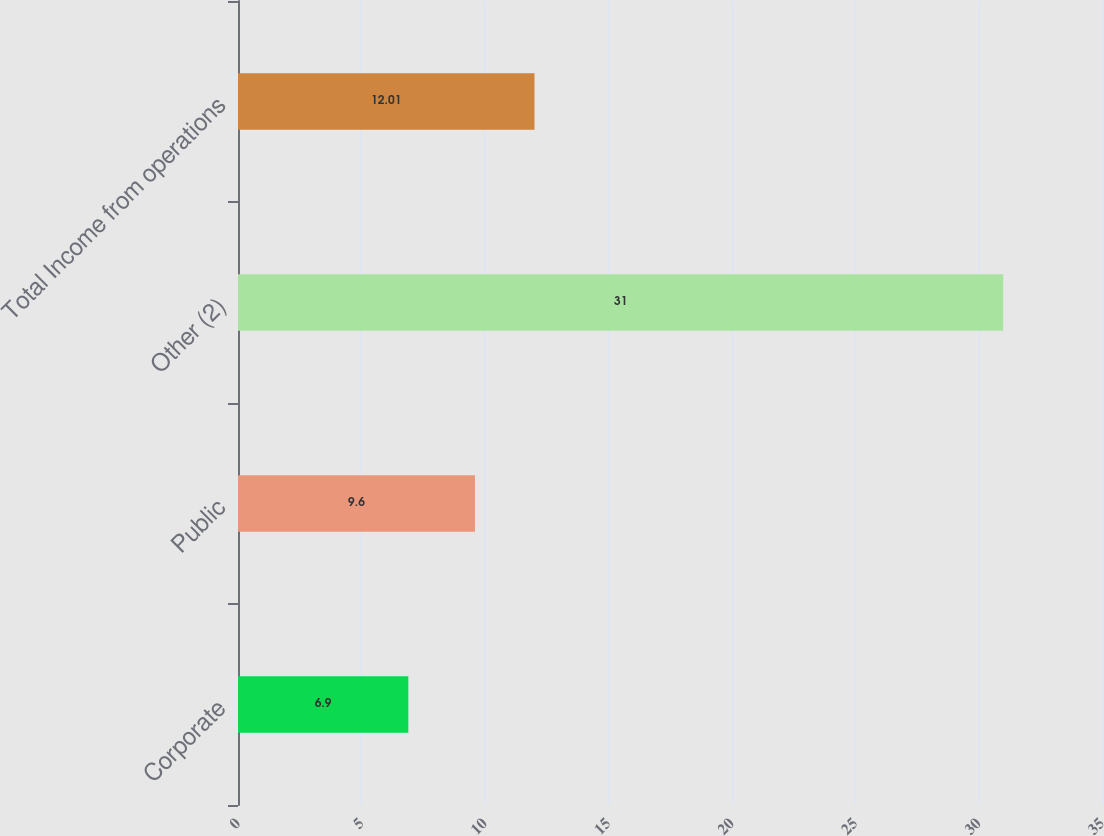Convert chart to OTSL. <chart><loc_0><loc_0><loc_500><loc_500><bar_chart><fcel>Corporate<fcel>Public<fcel>Other (2)<fcel>Total Income from operations<nl><fcel>6.9<fcel>9.6<fcel>31<fcel>12.01<nl></chart> 